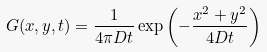Convert formula to latex. <formula><loc_0><loc_0><loc_500><loc_500>G ( x , y , t ) = \frac { 1 } { 4 \pi D t } \exp \left ( - \frac { x ^ { 2 } + y ^ { 2 } } { 4 D t } \right )</formula> 